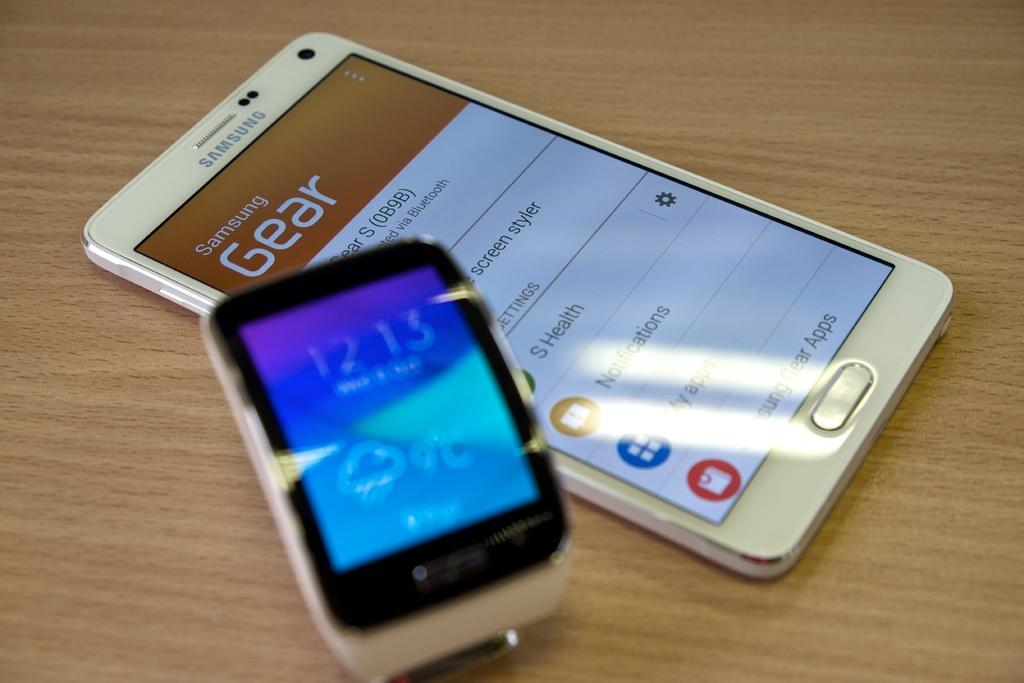<image>
Summarize the visual content of the image. A Samsung branded Gear cell phone with a smart watch sitting next to it. 